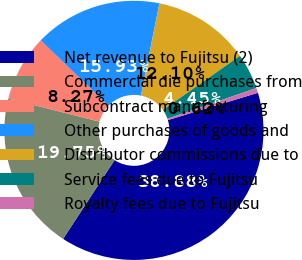Convert chart to OTSL. <chart><loc_0><loc_0><loc_500><loc_500><pie_chart><fcel>Net revenue to Fujitsu (2)<fcel>Commercial die purchases from<fcel>Subcontract manufacturing<fcel>Other purchases of goods and<fcel>Distributor commissions due to<fcel>Service fees due to Fujitsu<fcel>Royalty fees due to Fujitsu<nl><fcel>38.88%<fcel>19.75%<fcel>8.27%<fcel>15.93%<fcel>12.1%<fcel>4.45%<fcel>0.62%<nl></chart> 